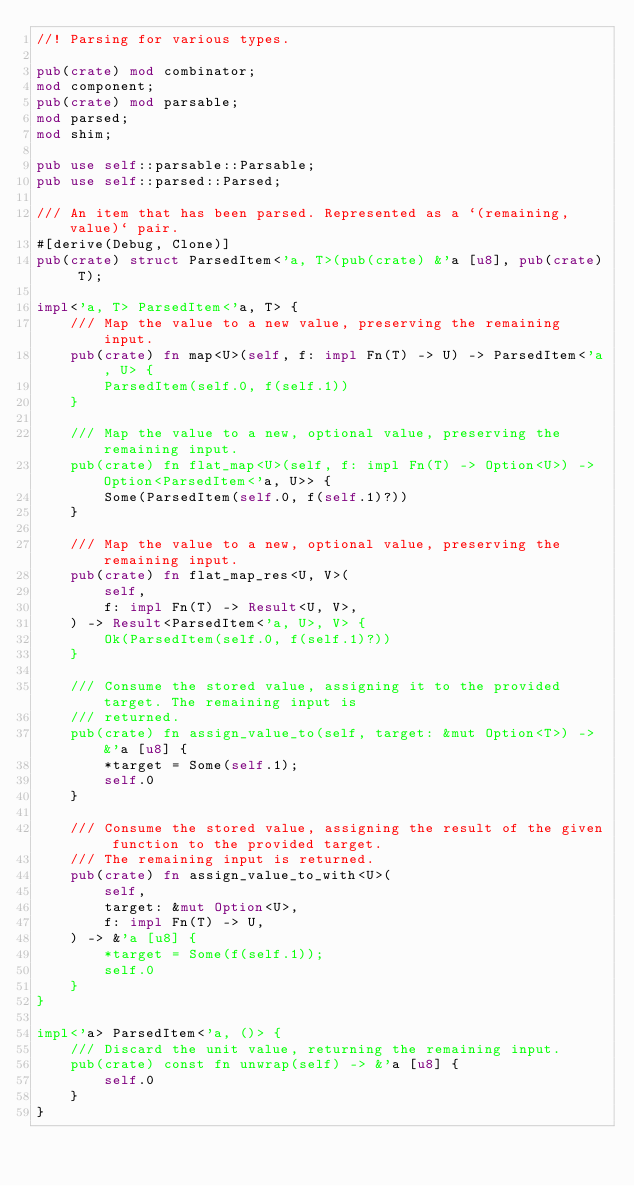<code> <loc_0><loc_0><loc_500><loc_500><_Rust_>//! Parsing for various types.

pub(crate) mod combinator;
mod component;
pub(crate) mod parsable;
mod parsed;
mod shim;

pub use self::parsable::Parsable;
pub use self::parsed::Parsed;

/// An item that has been parsed. Represented as a `(remaining, value)` pair.
#[derive(Debug, Clone)]
pub(crate) struct ParsedItem<'a, T>(pub(crate) &'a [u8], pub(crate) T);

impl<'a, T> ParsedItem<'a, T> {
    /// Map the value to a new value, preserving the remaining input.
    pub(crate) fn map<U>(self, f: impl Fn(T) -> U) -> ParsedItem<'a, U> {
        ParsedItem(self.0, f(self.1))
    }

    /// Map the value to a new, optional value, preserving the remaining input.
    pub(crate) fn flat_map<U>(self, f: impl Fn(T) -> Option<U>) -> Option<ParsedItem<'a, U>> {
        Some(ParsedItem(self.0, f(self.1)?))
    }

    /// Map the value to a new, optional value, preserving the remaining input.
    pub(crate) fn flat_map_res<U, V>(
        self,
        f: impl Fn(T) -> Result<U, V>,
    ) -> Result<ParsedItem<'a, U>, V> {
        Ok(ParsedItem(self.0, f(self.1)?))
    }

    /// Consume the stored value, assigning it to the provided target. The remaining input is
    /// returned.
    pub(crate) fn assign_value_to(self, target: &mut Option<T>) -> &'a [u8] {
        *target = Some(self.1);
        self.0
    }

    /// Consume the stored value, assigning the result of the given function to the provided target.
    /// The remaining input is returned.
    pub(crate) fn assign_value_to_with<U>(
        self,
        target: &mut Option<U>,
        f: impl Fn(T) -> U,
    ) -> &'a [u8] {
        *target = Some(f(self.1));
        self.0
    }
}

impl<'a> ParsedItem<'a, ()> {
    /// Discard the unit value, returning the remaining input.
    pub(crate) const fn unwrap(self) -> &'a [u8] {
        self.0
    }
}
</code> 